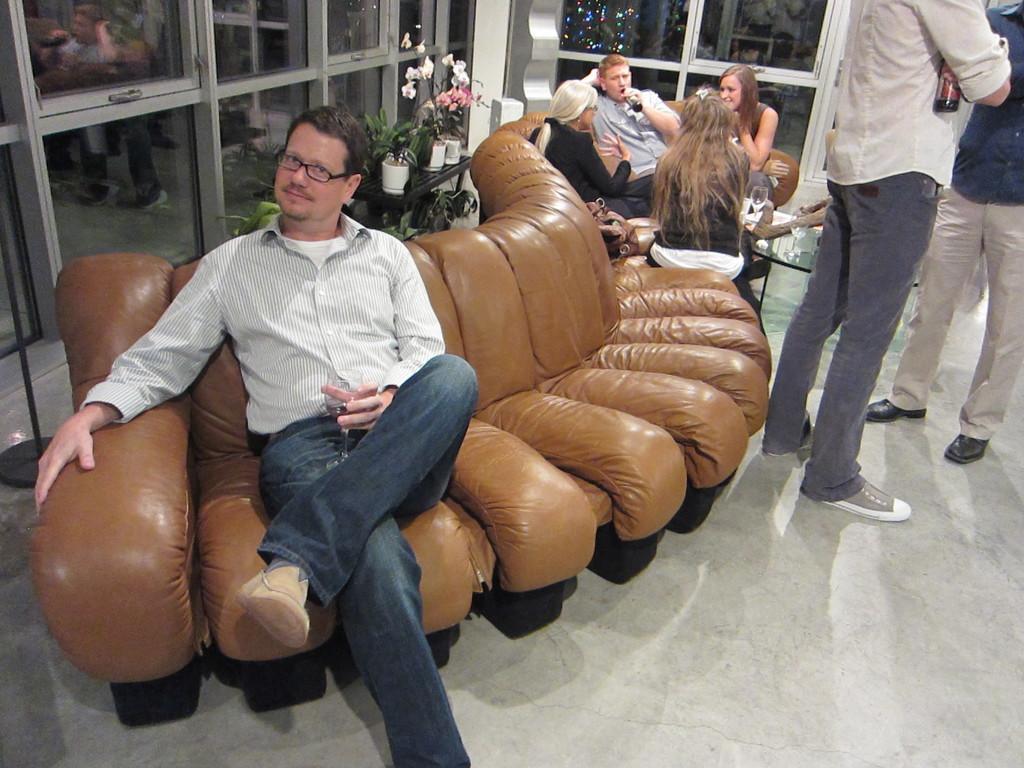Please provide a concise description of this image. Few people sitting on a sofa and these two people standing,this man holding a glass and this person holding a bottle,beside this woman we can see a bag. We can see glasses and objects on the table. In the background we can see glass windows and house plants. 